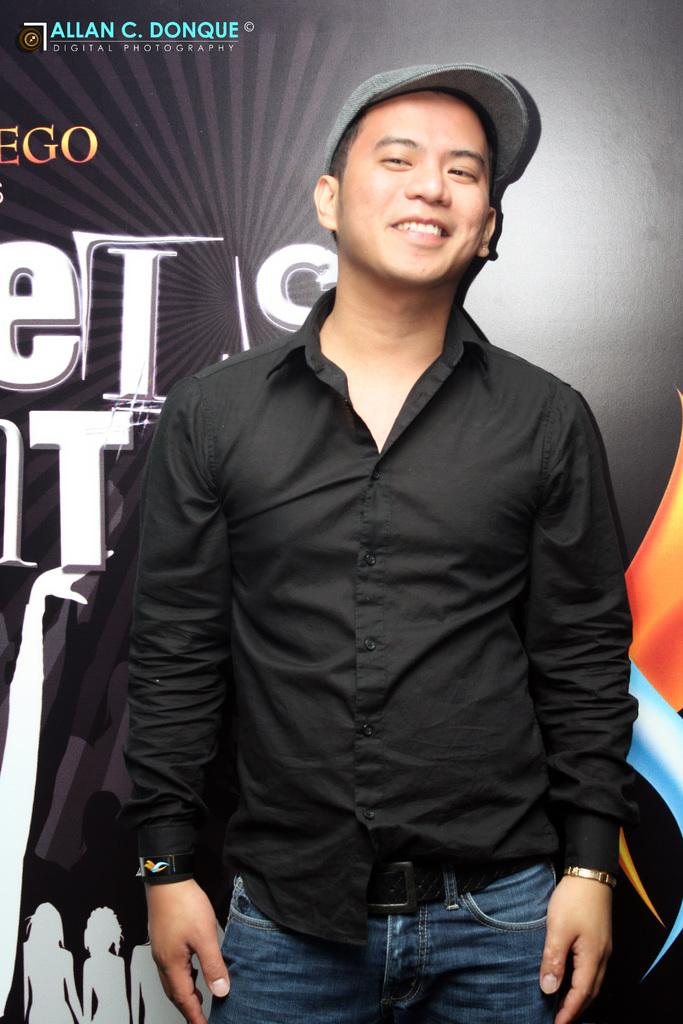Where was the image taken? The image was taken indoors. Who is present in the image? There is a man in the image. What is the man doing in the image? The man is standing. What is the man wearing in the image? The man is wearing a black shirt and blue jeans. What accessory is the man wearing in the image? The man is wearing a cap. What can be seen in the background of the image? There is a black-colored banner in the background. What type of wristwatch is the man wearing in the image? There is no wristwatch visible in the image. What account does the man have in the image? There is no mention of an account in the image. 